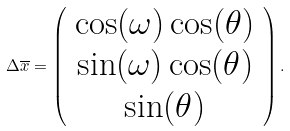<formula> <loc_0><loc_0><loc_500><loc_500>\Delta \overline { x } = \left ( \begin{array} { c } \cos ( \omega ) \cos ( \theta ) \\ \sin ( \omega ) \cos ( \theta ) \\ \sin ( \theta ) \end{array} \right ) .</formula> 